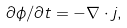<formula> <loc_0><loc_0><loc_500><loc_500>\partial \phi / \partial t = - \nabla \cdot j ,</formula> 